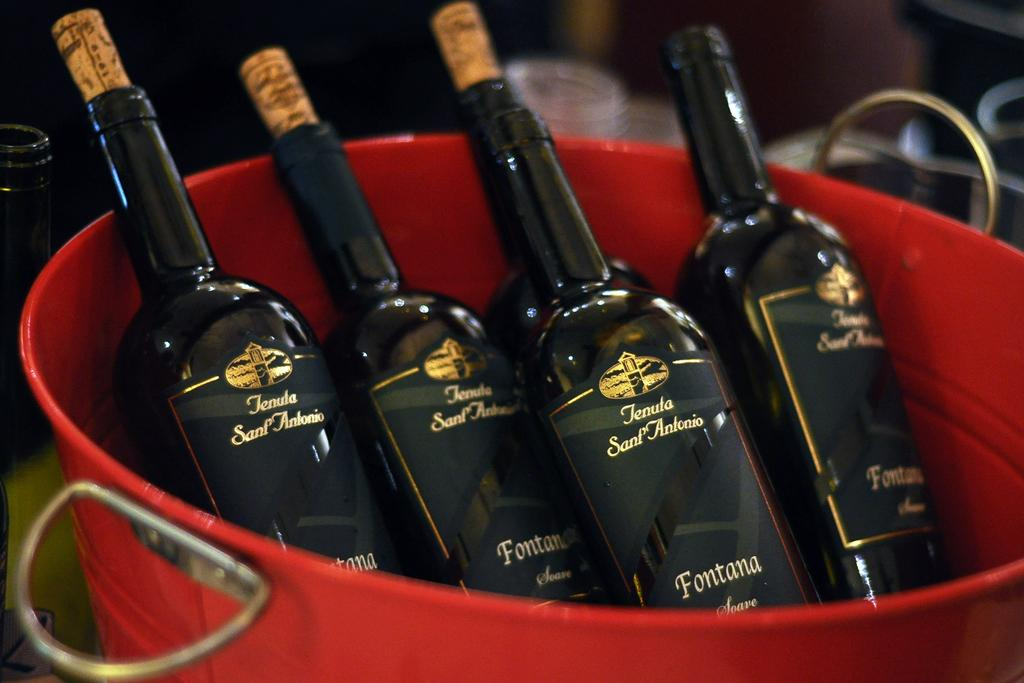How many glass bottles are visible in the image? There are five glass bottles in the image. What color are the glass bottles? The bottles are black in color. Where are the bottles placed in the image? The bottles are placed in a red object that resembles a tub. Can you describe the background of the image? The background of the image is blurred. What type of wine is being served in the glass bottles in the image? There is no indication of wine or any liquid in the glass bottles in the image. Can you see a monkey holding a frame in the image? There is no monkey or frame present in the image. 